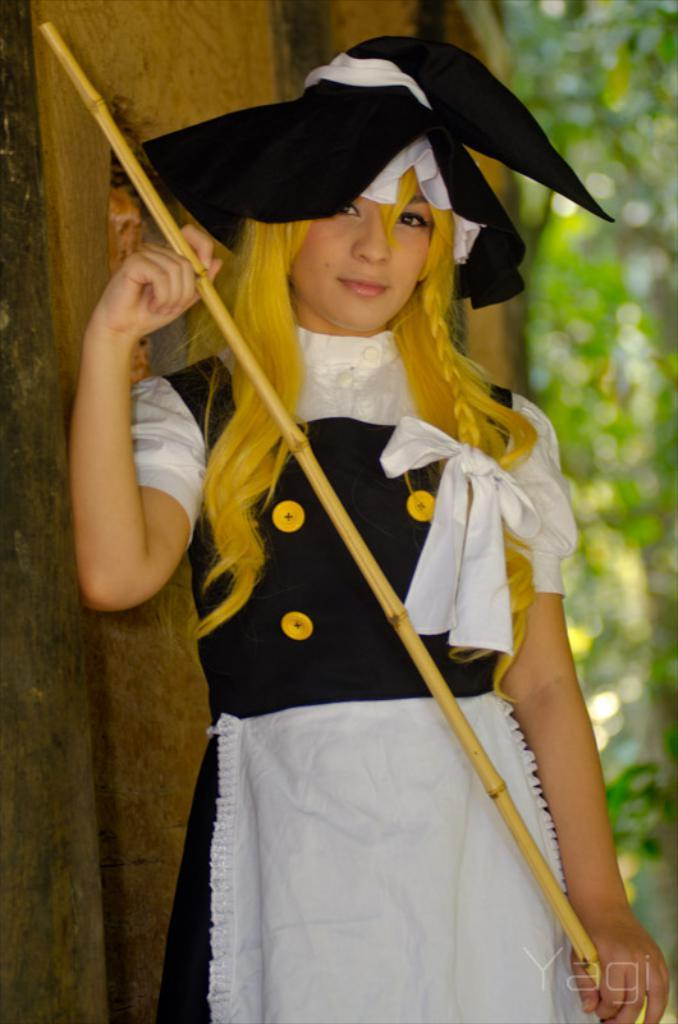Who is present in the image? There is a woman in the image. What is the woman wearing? The woman is wearing a dress and a cap. What is the woman holding in her hand? The woman is holding a stick in her hand. What can be seen in the background of the image? There are trees in the background of the image. What is written at the bottom of the image? There is text visible at the bottom of the image. How many trucks are visible in the image? There are no trucks visible in the image. What is the limit of the cap the woman is wearing in the image? The cap the woman is wearing does not have a limit; it is a physical object and not a rule or restriction. 